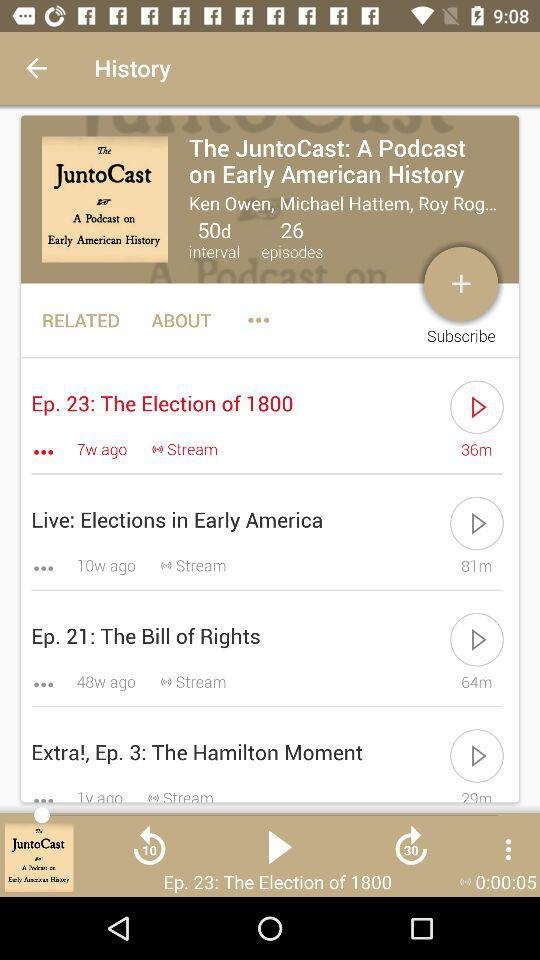How many episodes are there in "The JuntoCast"? There are 26 episodes of "The JuntoCast". 